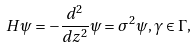Convert formula to latex. <formula><loc_0><loc_0><loc_500><loc_500>H \psi = - \frac { d ^ { 2 } } { d z ^ { 2 } } \psi = \sigma ^ { 2 } \psi , \gamma \in \Gamma ,</formula> 